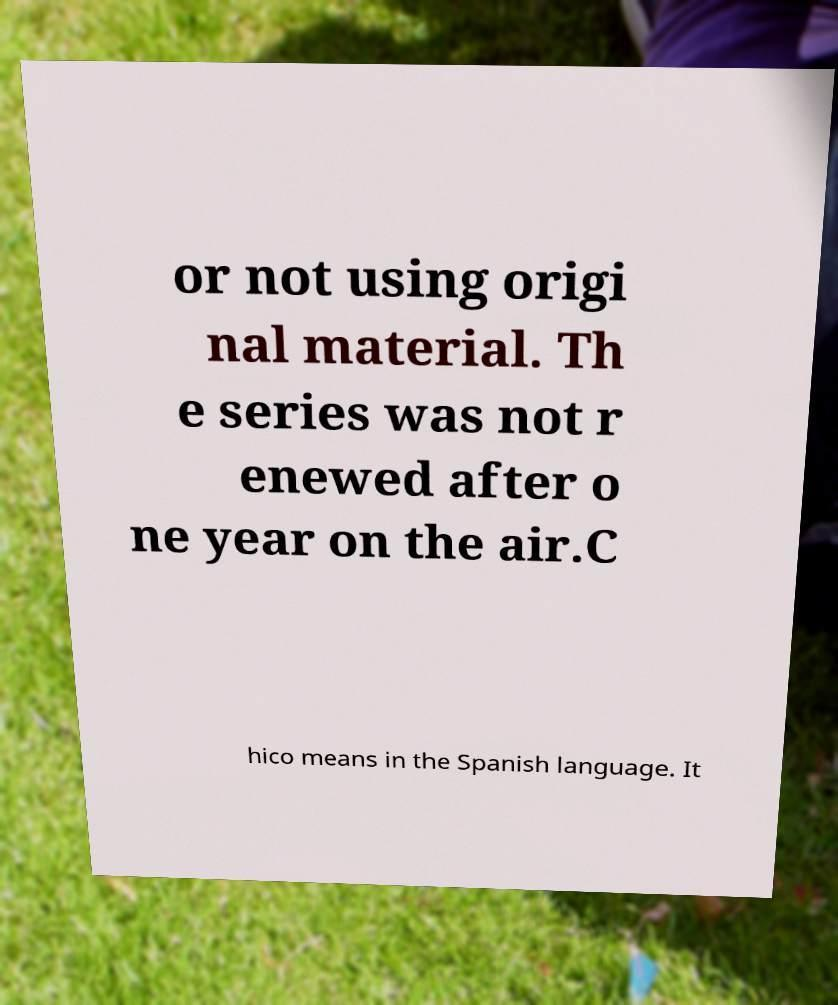There's text embedded in this image that I need extracted. Can you transcribe it verbatim? or not using origi nal material. Th e series was not r enewed after o ne year on the air.C hico means in the Spanish language. It 